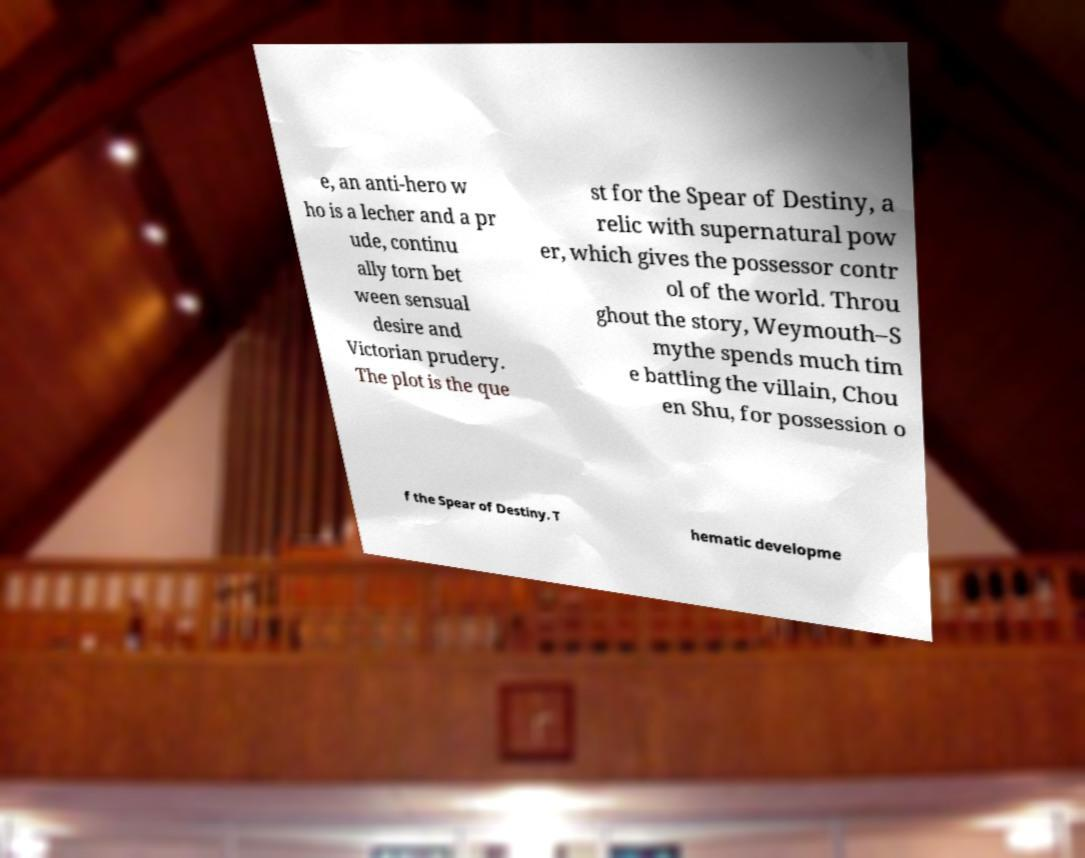For documentation purposes, I need the text within this image transcribed. Could you provide that? e, an anti-hero w ho is a lecher and a pr ude, continu ally torn bet ween sensual desire and Victorian prudery. The plot is the que st for the Spear of Destiny, a relic with supernatural pow er, which gives the possessor contr ol of the world. Throu ghout the story, Weymouth–S mythe spends much tim e battling the villain, Chou en Shu, for possession o f the Spear of Destiny. T hematic developme 